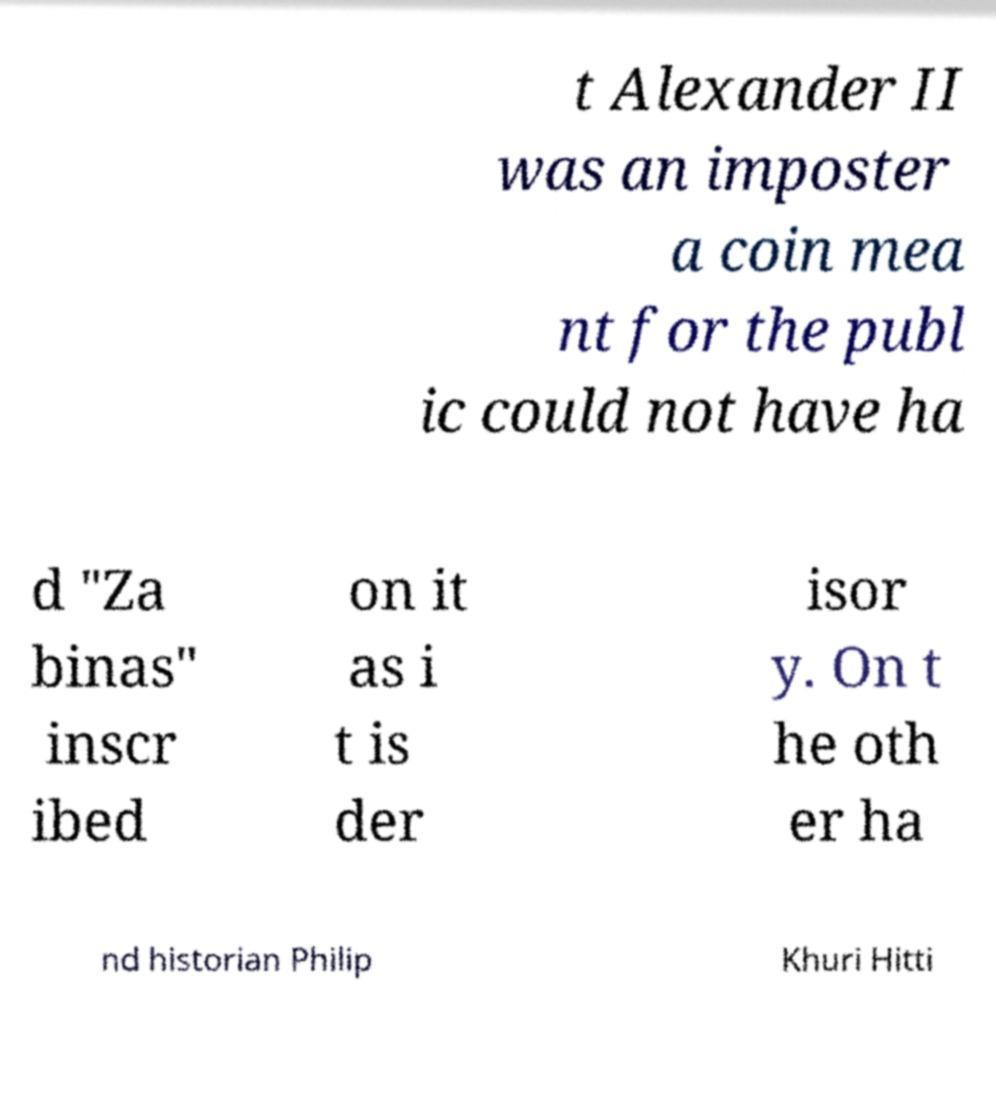Please read and relay the text visible in this image. What does it say? t Alexander II was an imposter a coin mea nt for the publ ic could not have ha d "Za binas" inscr ibed on it as i t is der isor y. On t he oth er ha nd historian Philip Khuri Hitti 